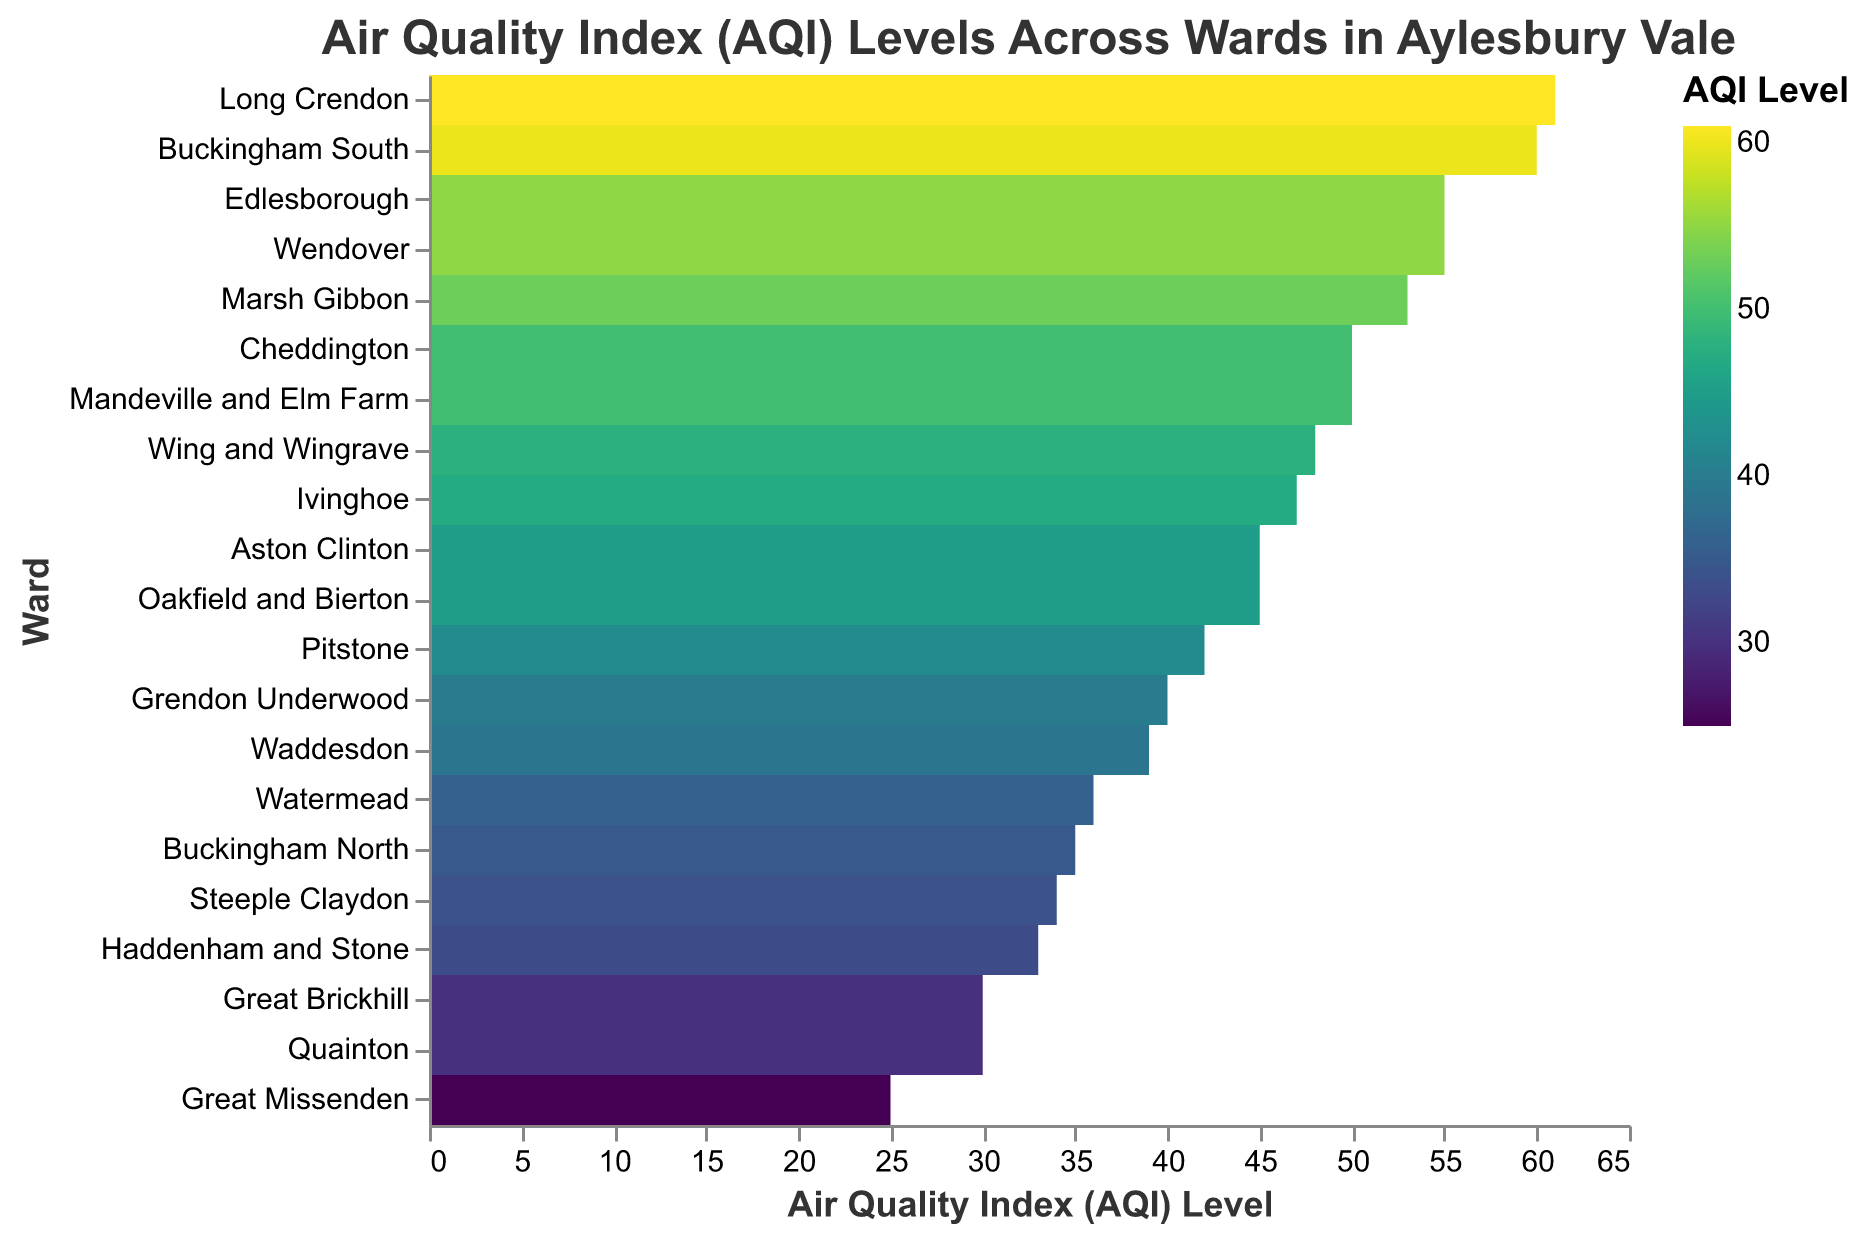What's the title of the figure? The title is usually found at the top of the figure; it provides a brief description of what the figure is depicting. The title of this heatmap is "Air Quality Index (AQI) Levels Across Wards in Aylesbury Vale."
Answer: Air Quality Index (AQI) Levels Across Wards in Aylesbury Vale Which ward has the highest AQI level? First, identify the highest AQI level visible on the figure. Then, find the corresponding ward for this AQI level. The highest AQI level is 61 and corresponds to Long Crendon.
Answer: Long Crendon How many wards have an AQI level above 50? Count the number of wards with AQI values greater than 50. The wards are Buckingham South (60), Edlesborough (55), Long Crendon (61), Marsh Gibbon (53), Wendover (55). There are 5 wards in total.
Answer: 5 What is the AQI level of Watermead? Locate the ward "Watermead" on the y-axis, then look across to the corresponding AQI level on the x-axis. The AQI level for Watermead is 36.
Answer: 36 Which wards have an AQI level of 30? Identify wards with the AQI level of 30 by cross-referencing the AQI level of 30 on the x-axis with the corresponding wards on the y-axis. The wards are Great Brickhill and Quainton.
Answer: Great Brickhill, Quainton What's the difference in AQI level between Haddenham and Stone and Buckingham North? Find the AQI levels for both wards, which are 33 for Haddenham and Stone and 35 for Buckingham North. The difference is 35 - 33 = 2.
Answer: 2 Which ward has a lower AQI level: Pitstone or Wing and Wingrave? Compare the AQI levels for both wards. Pitstone has an AQI level of 42, while Wing and Wingrave has an AQI level of 48. The lower AQI level is 42, which belongs to Pitstone.
Answer: Pitstone What is the average AQI level of the wards Oakfield and Bierton, Aston Clinton, and Ivinghoe? Sum the AQI levels of the wards: Oakfield and Bierton (45), Aston Clinton (45), and Ivinghoe (47). The sum is 45 + 45 + 47 = 137. Divide the sum by the number of wards: 137 / 3 = 45.67.
Answer: 45.67 